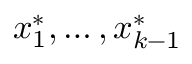Convert formula to latex. <formula><loc_0><loc_0><loc_500><loc_500>x _ { 1 } ^ { * } , \dots , x _ { k - 1 } ^ { * }</formula> 